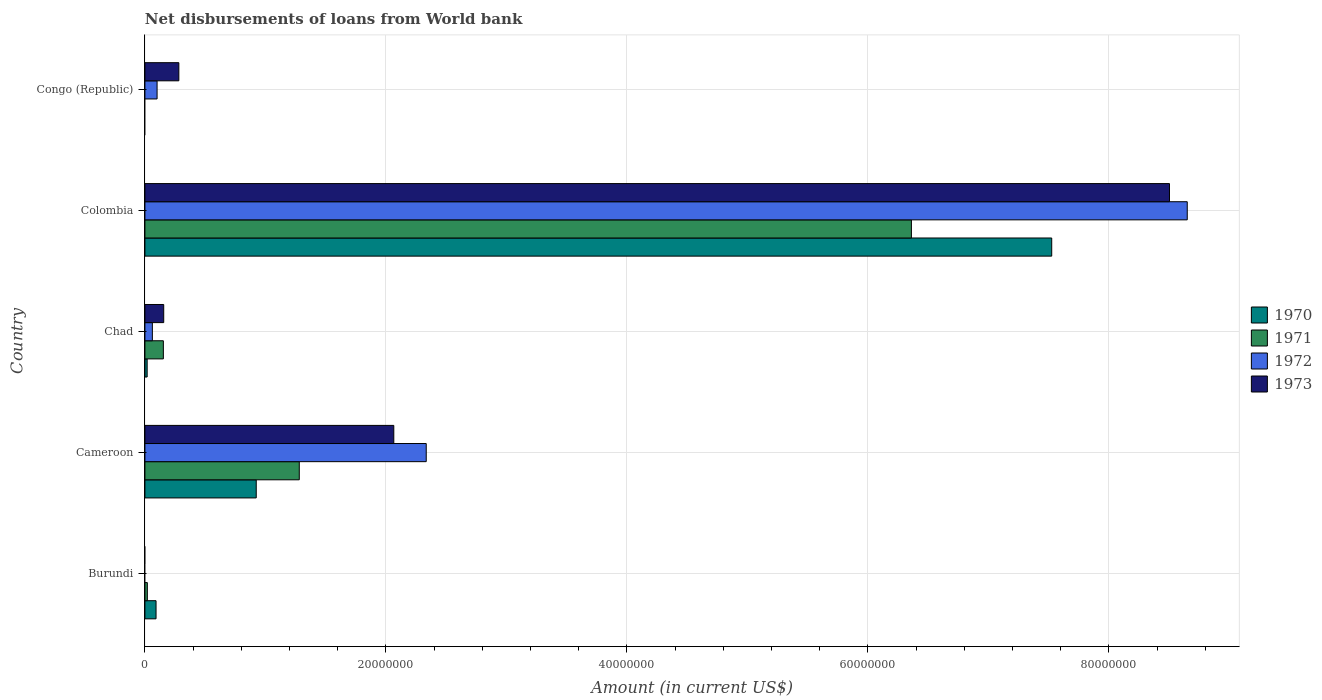How many groups of bars are there?
Your answer should be very brief. 5. What is the label of the 1st group of bars from the top?
Your answer should be compact. Congo (Republic). In how many cases, is the number of bars for a given country not equal to the number of legend labels?
Ensure brevity in your answer.  2. What is the amount of loan disbursed from World Bank in 1973 in Congo (Republic)?
Offer a very short reply. 2.82e+06. Across all countries, what is the maximum amount of loan disbursed from World Bank in 1971?
Offer a very short reply. 6.36e+07. Across all countries, what is the minimum amount of loan disbursed from World Bank in 1973?
Keep it short and to the point. 0. In which country was the amount of loan disbursed from World Bank in 1972 maximum?
Make the answer very short. Colombia. What is the total amount of loan disbursed from World Bank in 1970 in the graph?
Provide a short and direct response. 8.56e+07. What is the difference between the amount of loan disbursed from World Bank in 1972 in Cameroon and that in Congo (Republic)?
Give a very brief answer. 2.23e+07. What is the difference between the amount of loan disbursed from World Bank in 1970 in Chad and the amount of loan disbursed from World Bank in 1971 in Cameroon?
Ensure brevity in your answer.  -1.26e+07. What is the average amount of loan disbursed from World Bank in 1973 per country?
Keep it short and to the point. 2.20e+07. What is the difference between the amount of loan disbursed from World Bank in 1971 and amount of loan disbursed from World Bank in 1970 in Cameroon?
Your answer should be compact. 3.57e+06. In how many countries, is the amount of loan disbursed from World Bank in 1972 greater than 28000000 US$?
Your answer should be very brief. 1. What is the ratio of the amount of loan disbursed from World Bank in 1973 in Chad to that in Colombia?
Your response must be concise. 0.02. Is the difference between the amount of loan disbursed from World Bank in 1971 in Burundi and Cameroon greater than the difference between the amount of loan disbursed from World Bank in 1970 in Burundi and Cameroon?
Keep it short and to the point. No. What is the difference between the highest and the second highest amount of loan disbursed from World Bank in 1971?
Give a very brief answer. 5.08e+07. What is the difference between the highest and the lowest amount of loan disbursed from World Bank in 1973?
Ensure brevity in your answer.  8.50e+07. In how many countries, is the amount of loan disbursed from World Bank in 1971 greater than the average amount of loan disbursed from World Bank in 1971 taken over all countries?
Provide a short and direct response. 1. Is the sum of the amount of loan disbursed from World Bank in 1970 in Burundi and Cameroon greater than the maximum amount of loan disbursed from World Bank in 1973 across all countries?
Offer a very short reply. No. Is it the case that in every country, the sum of the amount of loan disbursed from World Bank in 1970 and amount of loan disbursed from World Bank in 1971 is greater than the sum of amount of loan disbursed from World Bank in 1972 and amount of loan disbursed from World Bank in 1973?
Your answer should be compact. No. Is it the case that in every country, the sum of the amount of loan disbursed from World Bank in 1971 and amount of loan disbursed from World Bank in 1973 is greater than the amount of loan disbursed from World Bank in 1972?
Your answer should be compact. Yes. How many bars are there?
Give a very brief answer. 16. Does the graph contain any zero values?
Your answer should be compact. Yes. Where does the legend appear in the graph?
Keep it short and to the point. Center right. How many legend labels are there?
Provide a short and direct response. 4. What is the title of the graph?
Your response must be concise. Net disbursements of loans from World bank. What is the label or title of the Y-axis?
Offer a terse response. Country. What is the Amount (in current US$) in 1970 in Burundi?
Offer a terse response. 9.23e+05. What is the Amount (in current US$) in 1971 in Burundi?
Provide a short and direct response. 2.01e+05. What is the Amount (in current US$) of 1972 in Burundi?
Give a very brief answer. 0. What is the Amount (in current US$) of 1970 in Cameroon?
Provide a succinct answer. 9.24e+06. What is the Amount (in current US$) of 1971 in Cameroon?
Keep it short and to the point. 1.28e+07. What is the Amount (in current US$) in 1972 in Cameroon?
Provide a short and direct response. 2.33e+07. What is the Amount (in current US$) of 1973 in Cameroon?
Your answer should be very brief. 2.07e+07. What is the Amount (in current US$) in 1970 in Chad?
Provide a short and direct response. 1.86e+05. What is the Amount (in current US$) in 1971 in Chad?
Provide a short and direct response. 1.53e+06. What is the Amount (in current US$) of 1972 in Chad?
Offer a terse response. 6.17e+05. What is the Amount (in current US$) of 1973 in Chad?
Your answer should be very brief. 1.56e+06. What is the Amount (in current US$) in 1970 in Colombia?
Offer a terse response. 7.53e+07. What is the Amount (in current US$) of 1971 in Colombia?
Offer a very short reply. 6.36e+07. What is the Amount (in current US$) in 1972 in Colombia?
Make the answer very short. 8.65e+07. What is the Amount (in current US$) of 1973 in Colombia?
Give a very brief answer. 8.50e+07. What is the Amount (in current US$) of 1971 in Congo (Republic)?
Make the answer very short. 0. What is the Amount (in current US$) of 1972 in Congo (Republic)?
Your answer should be compact. 1.01e+06. What is the Amount (in current US$) of 1973 in Congo (Republic)?
Ensure brevity in your answer.  2.82e+06. Across all countries, what is the maximum Amount (in current US$) of 1970?
Provide a succinct answer. 7.53e+07. Across all countries, what is the maximum Amount (in current US$) of 1971?
Keep it short and to the point. 6.36e+07. Across all countries, what is the maximum Amount (in current US$) of 1972?
Provide a succinct answer. 8.65e+07. Across all countries, what is the maximum Amount (in current US$) of 1973?
Provide a succinct answer. 8.50e+07. Across all countries, what is the minimum Amount (in current US$) of 1971?
Offer a very short reply. 0. Across all countries, what is the minimum Amount (in current US$) of 1972?
Your answer should be compact. 0. What is the total Amount (in current US$) of 1970 in the graph?
Your response must be concise. 8.56e+07. What is the total Amount (in current US$) of 1971 in the graph?
Give a very brief answer. 7.82e+07. What is the total Amount (in current US$) in 1972 in the graph?
Offer a terse response. 1.11e+08. What is the total Amount (in current US$) in 1973 in the graph?
Offer a very short reply. 1.10e+08. What is the difference between the Amount (in current US$) of 1970 in Burundi and that in Cameroon?
Your answer should be compact. -8.32e+06. What is the difference between the Amount (in current US$) of 1971 in Burundi and that in Cameroon?
Your answer should be compact. -1.26e+07. What is the difference between the Amount (in current US$) in 1970 in Burundi and that in Chad?
Provide a succinct answer. 7.37e+05. What is the difference between the Amount (in current US$) in 1971 in Burundi and that in Chad?
Make the answer very short. -1.33e+06. What is the difference between the Amount (in current US$) in 1970 in Burundi and that in Colombia?
Make the answer very short. -7.43e+07. What is the difference between the Amount (in current US$) in 1971 in Burundi and that in Colombia?
Offer a terse response. -6.34e+07. What is the difference between the Amount (in current US$) of 1970 in Cameroon and that in Chad?
Your answer should be compact. 9.05e+06. What is the difference between the Amount (in current US$) in 1971 in Cameroon and that in Chad?
Make the answer very short. 1.13e+07. What is the difference between the Amount (in current US$) of 1972 in Cameroon and that in Chad?
Offer a very short reply. 2.27e+07. What is the difference between the Amount (in current US$) of 1973 in Cameroon and that in Chad?
Make the answer very short. 1.91e+07. What is the difference between the Amount (in current US$) in 1970 in Cameroon and that in Colombia?
Give a very brief answer. -6.60e+07. What is the difference between the Amount (in current US$) in 1971 in Cameroon and that in Colombia?
Your answer should be compact. -5.08e+07. What is the difference between the Amount (in current US$) in 1972 in Cameroon and that in Colombia?
Keep it short and to the point. -6.32e+07. What is the difference between the Amount (in current US$) in 1973 in Cameroon and that in Colombia?
Offer a terse response. -6.44e+07. What is the difference between the Amount (in current US$) in 1972 in Cameroon and that in Congo (Republic)?
Offer a terse response. 2.23e+07. What is the difference between the Amount (in current US$) in 1973 in Cameroon and that in Congo (Republic)?
Give a very brief answer. 1.78e+07. What is the difference between the Amount (in current US$) in 1970 in Chad and that in Colombia?
Provide a short and direct response. -7.51e+07. What is the difference between the Amount (in current US$) of 1971 in Chad and that in Colombia?
Offer a terse response. -6.21e+07. What is the difference between the Amount (in current US$) of 1972 in Chad and that in Colombia?
Offer a terse response. -8.59e+07. What is the difference between the Amount (in current US$) of 1973 in Chad and that in Colombia?
Your response must be concise. -8.35e+07. What is the difference between the Amount (in current US$) of 1972 in Chad and that in Congo (Republic)?
Give a very brief answer. -3.92e+05. What is the difference between the Amount (in current US$) in 1973 in Chad and that in Congo (Republic)?
Offer a terse response. -1.26e+06. What is the difference between the Amount (in current US$) of 1972 in Colombia and that in Congo (Republic)?
Your answer should be compact. 8.55e+07. What is the difference between the Amount (in current US$) in 1973 in Colombia and that in Congo (Republic)?
Offer a very short reply. 8.22e+07. What is the difference between the Amount (in current US$) of 1970 in Burundi and the Amount (in current US$) of 1971 in Cameroon?
Offer a very short reply. -1.19e+07. What is the difference between the Amount (in current US$) of 1970 in Burundi and the Amount (in current US$) of 1972 in Cameroon?
Ensure brevity in your answer.  -2.24e+07. What is the difference between the Amount (in current US$) of 1970 in Burundi and the Amount (in current US$) of 1973 in Cameroon?
Keep it short and to the point. -1.97e+07. What is the difference between the Amount (in current US$) of 1971 in Burundi and the Amount (in current US$) of 1972 in Cameroon?
Offer a terse response. -2.31e+07. What is the difference between the Amount (in current US$) of 1971 in Burundi and the Amount (in current US$) of 1973 in Cameroon?
Your response must be concise. -2.05e+07. What is the difference between the Amount (in current US$) in 1970 in Burundi and the Amount (in current US$) in 1971 in Chad?
Ensure brevity in your answer.  -6.07e+05. What is the difference between the Amount (in current US$) of 1970 in Burundi and the Amount (in current US$) of 1972 in Chad?
Offer a very short reply. 3.06e+05. What is the difference between the Amount (in current US$) of 1970 in Burundi and the Amount (in current US$) of 1973 in Chad?
Provide a succinct answer. -6.37e+05. What is the difference between the Amount (in current US$) in 1971 in Burundi and the Amount (in current US$) in 1972 in Chad?
Keep it short and to the point. -4.16e+05. What is the difference between the Amount (in current US$) in 1971 in Burundi and the Amount (in current US$) in 1973 in Chad?
Offer a terse response. -1.36e+06. What is the difference between the Amount (in current US$) in 1970 in Burundi and the Amount (in current US$) in 1971 in Colombia?
Offer a very short reply. -6.27e+07. What is the difference between the Amount (in current US$) in 1970 in Burundi and the Amount (in current US$) in 1972 in Colombia?
Keep it short and to the point. -8.56e+07. What is the difference between the Amount (in current US$) of 1970 in Burundi and the Amount (in current US$) of 1973 in Colombia?
Ensure brevity in your answer.  -8.41e+07. What is the difference between the Amount (in current US$) of 1971 in Burundi and the Amount (in current US$) of 1972 in Colombia?
Your answer should be very brief. -8.63e+07. What is the difference between the Amount (in current US$) of 1971 in Burundi and the Amount (in current US$) of 1973 in Colombia?
Your response must be concise. -8.48e+07. What is the difference between the Amount (in current US$) in 1970 in Burundi and the Amount (in current US$) in 1972 in Congo (Republic)?
Your response must be concise. -8.60e+04. What is the difference between the Amount (in current US$) of 1970 in Burundi and the Amount (in current US$) of 1973 in Congo (Republic)?
Make the answer very short. -1.89e+06. What is the difference between the Amount (in current US$) in 1971 in Burundi and the Amount (in current US$) in 1972 in Congo (Republic)?
Give a very brief answer. -8.08e+05. What is the difference between the Amount (in current US$) in 1971 in Burundi and the Amount (in current US$) in 1973 in Congo (Republic)?
Your answer should be compact. -2.62e+06. What is the difference between the Amount (in current US$) in 1970 in Cameroon and the Amount (in current US$) in 1971 in Chad?
Provide a succinct answer. 7.71e+06. What is the difference between the Amount (in current US$) of 1970 in Cameroon and the Amount (in current US$) of 1972 in Chad?
Offer a terse response. 8.62e+06. What is the difference between the Amount (in current US$) of 1970 in Cameroon and the Amount (in current US$) of 1973 in Chad?
Make the answer very short. 7.68e+06. What is the difference between the Amount (in current US$) of 1971 in Cameroon and the Amount (in current US$) of 1972 in Chad?
Provide a short and direct response. 1.22e+07. What is the difference between the Amount (in current US$) of 1971 in Cameroon and the Amount (in current US$) of 1973 in Chad?
Keep it short and to the point. 1.13e+07. What is the difference between the Amount (in current US$) of 1972 in Cameroon and the Amount (in current US$) of 1973 in Chad?
Your answer should be very brief. 2.18e+07. What is the difference between the Amount (in current US$) in 1970 in Cameroon and the Amount (in current US$) in 1971 in Colombia?
Your answer should be very brief. -5.44e+07. What is the difference between the Amount (in current US$) in 1970 in Cameroon and the Amount (in current US$) in 1972 in Colombia?
Offer a very short reply. -7.73e+07. What is the difference between the Amount (in current US$) in 1970 in Cameroon and the Amount (in current US$) in 1973 in Colombia?
Offer a terse response. -7.58e+07. What is the difference between the Amount (in current US$) in 1971 in Cameroon and the Amount (in current US$) in 1972 in Colombia?
Offer a terse response. -7.37e+07. What is the difference between the Amount (in current US$) in 1971 in Cameroon and the Amount (in current US$) in 1973 in Colombia?
Your answer should be compact. -7.22e+07. What is the difference between the Amount (in current US$) in 1972 in Cameroon and the Amount (in current US$) in 1973 in Colombia?
Provide a succinct answer. -6.17e+07. What is the difference between the Amount (in current US$) of 1970 in Cameroon and the Amount (in current US$) of 1972 in Congo (Republic)?
Your answer should be very brief. 8.23e+06. What is the difference between the Amount (in current US$) of 1970 in Cameroon and the Amount (in current US$) of 1973 in Congo (Republic)?
Your answer should be very brief. 6.42e+06. What is the difference between the Amount (in current US$) in 1971 in Cameroon and the Amount (in current US$) in 1972 in Congo (Republic)?
Keep it short and to the point. 1.18e+07. What is the difference between the Amount (in current US$) in 1971 in Cameroon and the Amount (in current US$) in 1973 in Congo (Republic)?
Ensure brevity in your answer.  1.00e+07. What is the difference between the Amount (in current US$) of 1972 in Cameroon and the Amount (in current US$) of 1973 in Congo (Republic)?
Your response must be concise. 2.05e+07. What is the difference between the Amount (in current US$) in 1970 in Chad and the Amount (in current US$) in 1971 in Colombia?
Ensure brevity in your answer.  -6.34e+07. What is the difference between the Amount (in current US$) of 1970 in Chad and the Amount (in current US$) of 1972 in Colombia?
Your response must be concise. -8.63e+07. What is the difference between the Amount (in current US$) of 1970 in Chad and the Amount (in current US$) of 1973 in Colombia?
Offer a terse response. -8.48e+07. What is the difference between the Amount (in current US$) of 1971 in Chad and the Amount (in current US$) of 1972 in Colombia?
Provide a succinct answer. -8.50e+07. What is the difference between the Amount (in current US$) of 1971 in Chad and the Amount (in current US$) of 1973 in Colombia?
Make the answer very short. -8.35e+07. What is the difference between the Amount (in current US$) in 1972 in Chad and the Amount (in current US$) in 1973 in Colombia?
Give a very brief answer. -8.44e+07. What is the difference between the Amount (in current US$) of 1970 in Chad and the Amount (in current US$) of 1972 in Congo (Republic)?
Give a very brief answer. -8.23e+05. What is the difference between the Amount (in current US$) of 1970 in Chad and the Amount (in current US$) of 1973 in Congo (Republic)?
Provide a succinct answer. -2.63e+06. What is the difference between the Amount (in current US$) of 1971 in Chad and the Amount (in current US$) of 1972 in Congo (Republic)?
Offer a terse response. 5.21e+05. What is the difference between the Amount (in current US$) in 1971 in Chad and the Amount (in current US$) in 1973 in Congo (Republic)?
Give a very brief answer. -1.29e+06. What is the difference between the Amount (in current US$) in 1972 in Chad and the Amount (in current US$) in 1973 in Congo (Republic)?
Offer a very short reply. -2.20e+06. What is the difference between the Amount (in current US$) of 1970 in Colombia and the Amount (in current US$) of 1972 in Congo (Republic)?
Give a very brief answer. 7.42e+07. What is the difference between the Amount (in current US$) of 1970 in Colombia and the Amount (in current US$) of 1973 in Congo (Republic)?
Provide a succinct answer. 7.24e+07. What is the difference between the Amount (in current US$) of 1971 in Colombia and the Amount (in current US$) of 1972 in Congo (Republic)?
Ensure brevity in your answer.  6.26e+07. What is the difference between the Amount (in current US$) in 1971 in Colombia and the Amount (in current US$) in 1973 in Congo (Republic)?
Ensure brevity in your answer.  6.08e+07. What is the difference between the Amount (in current US$) in 1972 in Colombia and the Amount (in current US$) in 1973 in Congo (Republic)?
Offer a terse response. 8.37e+07. What is the average Amount (in current US$) in 1970 per country?
Ensure brevity in your answer.  1.71e+07. What is the average Amount (in current US$) in 1971 per country?
Your answer should be compact. 1.56e+07. What is the average Amount (in current US$) in 1972 per country?
Provide a succinct answer. 2.23e+07. What is the average Amount (in current US$) of 1973 per country?
Make the answer very short. 2.20e+07. What is the difference between the Amount (in current US$) in 1970 and Amount (in current US$) in 1971 in Burundi?
Give a very brief answer. 7.22e+05. What is the difference between the Amount (in current US$) in 1970 and Amount (in current US$) in 1971 in Cameroon?
Offer a very short reply. -3.57e+06. What is the difference between the Amount (in current US$) of 1970 and Amount (in current US$) of 1972 in Cameroon?
Your answer should be compact. -1.41e+07. What is the difference between the Amount (in current US$) of 1970 and Amount (in current US$) of 1973 in Cameroon?
Your response must be concise. -1.14e+07. What is the difference between the Amount (in current US$) of 1971 and Amount (in current US$) of 1972 in Cameroon?
Your answer should be compact. -1.05e+07. What is the difference between the Amount (in current US$) in 1971 and Amount (in current US$) in 1973 in Cameroon?
Offer a very short reply. -7.84e+06. What is the difference between the Amount (in current US$) in 1972 and Amount (in current US$) in 1973 in Cameroon?
Give a very brief answer. 2.69e+06. What is the difference between the Amount (in current US$) of 1970 and Amount (in current US$) of 1971 in Chad?
Make the answer very short. -1.34e+06. What is the difference between the Amount (in current US$) in 1970 and Amount (in current US$) in 1972 in Chad?
Offer a very short reply. -4.31e+05. What is the difference between the Amount (in current US$) of 1970 and Amount (in current US$) of 1973 in Chad?
Provide a succinct answer. -1.37e+06. What is the difference between the Amount (in current US$) in 1971 and Amount (in current US$) in 1972 in Chad?
Ensure brevity in your answer.  9.13e+05. What is the difference between the Amount (in current US$) in 1971 and Amount (in current US$) in 1973 in Chad?
Offer a terse response. -3.00e+04. What is the difference between the Amount (in current US$) of 1972 and Amount (in current US$) of 1973 in Chad?
Give a very brief answer. -9.43e+05. What is the difference between the Amount (in current US$) in 1970 and Amount (in current US$) in 1971 in Colombia?
Your response must be concise. 1.16e+07. What is the difference between the Amount (in current US$) in 1970 and Amount (in current US$) in 1972 in Colombia?
Your answer should be compact. -1.12e+07. What is the difference between the Amount (in current US$) of 1970 and Amount (in current US$) of 1973 in Colombia?
Your response must be concise. -9.77e+06. What is the difference between the Amount (in current US$) of 1971 and Amount (in current US$) of 1972 in Colombia?
Provide a succinct answer. -2.29e+07. What is the difference between the Amount (in current US$) of 1971 and Amount (in current US$) of 1973 in Colombia?
Make the answer very short. -2.14e+07. What is the difference between the Amount (in current US$) of 1972 and Amount (in current US$) of 1973 in Colombia?
Offer a very short reply. 1.47e+06. What is the difference between the Amount (in current US$) of 1972 and Amount (in current US$) of 1973 in Congo (Republic)?
Your response must be concise. -1.81e+06. What is the ratio of the Amount (in current US$) of 1970 in Burundi to that in Cameroon?
Offer a very short reply. 0.1. What is the ratio of the Amount (in current US$) in 1971 in Burundi to that in Cameroon?
Provide a succinct answer. 0.02. What is the ratio of the Amount (in current US$) of 1970 in Burundi to that in Chad?
Give a very brief answer. 4.96. What is the ratio of the Amount (in current US$) of 1971 in Burundi to that in Chad?
Provide a succinct answer. 0.13. What is the ratio of the Amount (in current US$) in 1970 in Burundi to that in Colombia?
Provide a succinct answer. 0.01. What is the ratio of the Amount (in current US$) of 1971 in Burundi to that in Colombia?
Your answer should be very brief. 0. What is the ratio of the Amount (in current US$) in 1970 in Cameroon to that in Chad?
Make the answer very short. 49.67. What is the ratio of the Amount (in current US$) of 1971 in Cameroon to that in Chad?
Ensure brevity in your answer.  8.37. What is the ratio of the Amount (in current US$) of 1972 in Cameroon to that in Chad?
Give a very brief answer. 37.84. What is the ratio of the Amount (in current US$) in 1973 in Cameroon to that in Chad?
Your answer should be compact. 13.24. What is the ratio of the Amount (in current US$) of 1970 in Cameroon to that in Colombia?
Your answer should be very brief. 0.12. What is the ratio of the Amount (in current US$) in 1971 in Cameroon to that in Colombia?
Your response must be concise. 0.2. What is the ratio of the Amount (in current US$) of 1972 in Cameroon to that in Colombia?
Keep it short and to the point. 0.27. What is the ratio of the Amount (in current US$) of 1973 in Cameroon to that in Colombia?
Your answer should be compact. 0.24. What is the ratio of the Amount (in current US$) of 1972 in Cameroon to that in Congo (Republic)?
Your response must be concise. 23.14. What is the ratio of the Amount (in current US$) in 1973 in Cameroon to that in Congo (Republic)?
Ensure brevity in your answer.  7.33. What is the ratio of the Amount (in current US$) of 1970 in Chad to that in Colombia?
Provide a succinct answer. 0. What is the ratio of the Amount (in current US$) of 1971 in Chad to that in Colombia?
Make the answer very short. 0.02. What is the ratio of the Amount (in current US$) in 1972 in Chad to that in Colombia?
Give a very brief answer. 0.01. What is the ratio of the Amount (in current US$) in 1973 in Chad to that in Colombia?
Offer a terse response. 0.02. What is the ratio of the Amount (in current US$) in 1972 in Chad to that in Congo (Republic)?
Your answer should be very brief. 0.61. What is the ratio of the Amount (in current US$) in 1973 in Chad to that in Congo (Republic)?
Offer a very short reply. 0.55. What is the ratio of the Amount (in current US$) of 1972 in Colombia to that in Congo (Republic)?
Your answer should be very brief. 85.74. What is the ratio of the Amount (in current US$) in 1973 in Colombia to that in Congo (Republic)?
Your answer should be compact. 30.2. What is the difference between the highest and the second highest Amount (in current US$) of 1970?
Offer a terse response. 6.60e+07. What is the difference between the highest and the second highest Amount (in current US$) of 1971?
Keep it short and to the point. 5.08e+07. What is the difference between the highest and the second highest Amount (in current US$) of 1972?
Offer a very short reply. 6.32e+07. What is the difference between the highest and the second highest Amount (in current US$) of 1973?
Make the answer very short. 6.44e+07. What is the difference between the highest and the lowest Amount (in current US$) in 1970?
Your response must be concise. 7.53e+07. What is the difference between the highest and the lowest Amount (in current US$) of 1971?
Your answer should be very brief. 6.36e+07. What is the difference between the highest and the lowest Amount (in current US$) in 1972?
Ensure brevity in your answer.  8.65e+07. What is the difference between the highest and the lowest Amount (in current US$) of 1973?
Keep it short and to the point. 8.50e+07. 